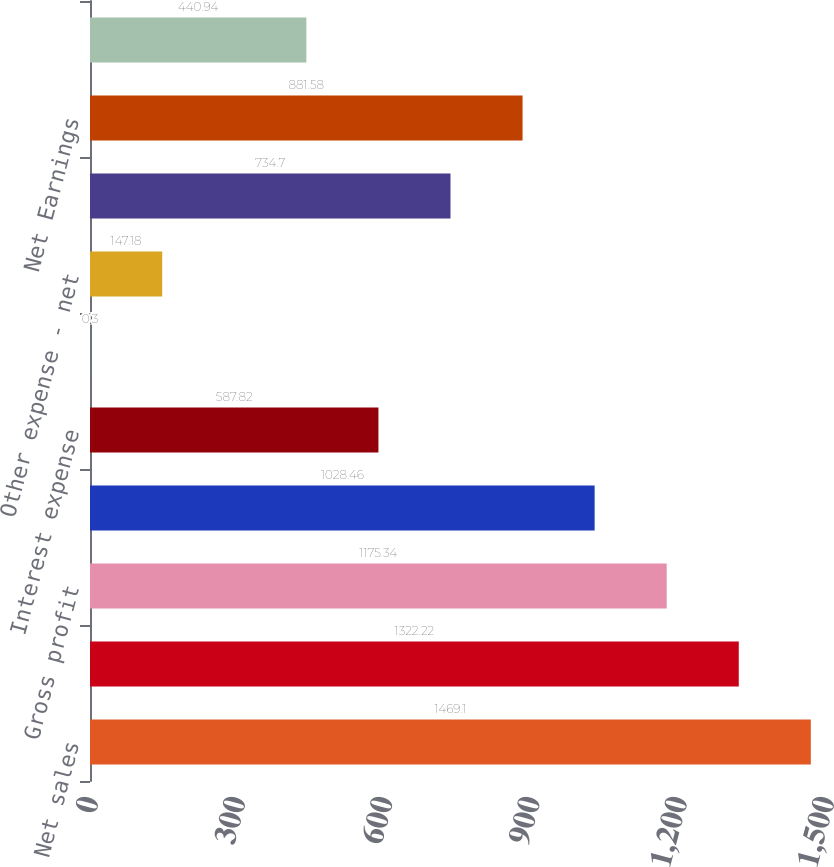<chart> <loc_0><loc_0><loc_500><loc_500><bar_chart><fcel>Net sales<fcel>Cost of products sold<fcel>Gross profit<fcel>Selling general and<fcel>Interest expense<fcel>Amortization of intangibles<fcel>Other expense - net<fcel>Provision for income taxes<fcel>Net Earnings<fcel>Net Earnings Per Share of<nl><fcel>1469.1<fcel>1322.22<fcel>1175.34<fcel>1028.46<fcel>587.82<fcel>0.3<fcel>147.18<fcel>734.7<fcel>881.58<fcel>440.94<nl></chart> 